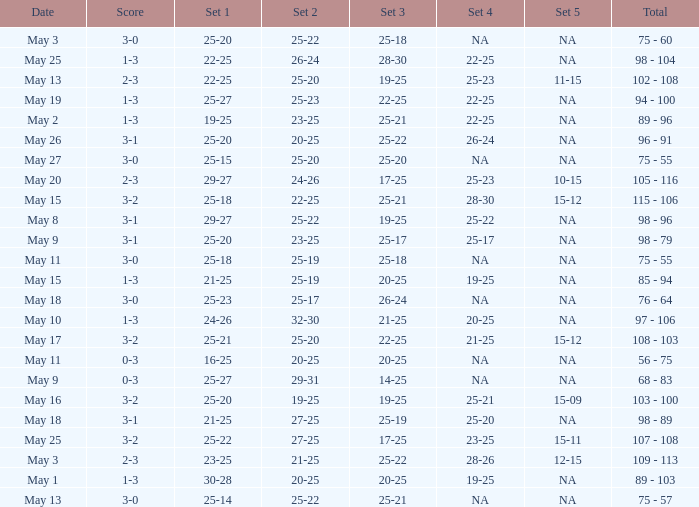What is the set 2 the has 1 set of 21-25, and 4 sets of 25-20? 27-25. 